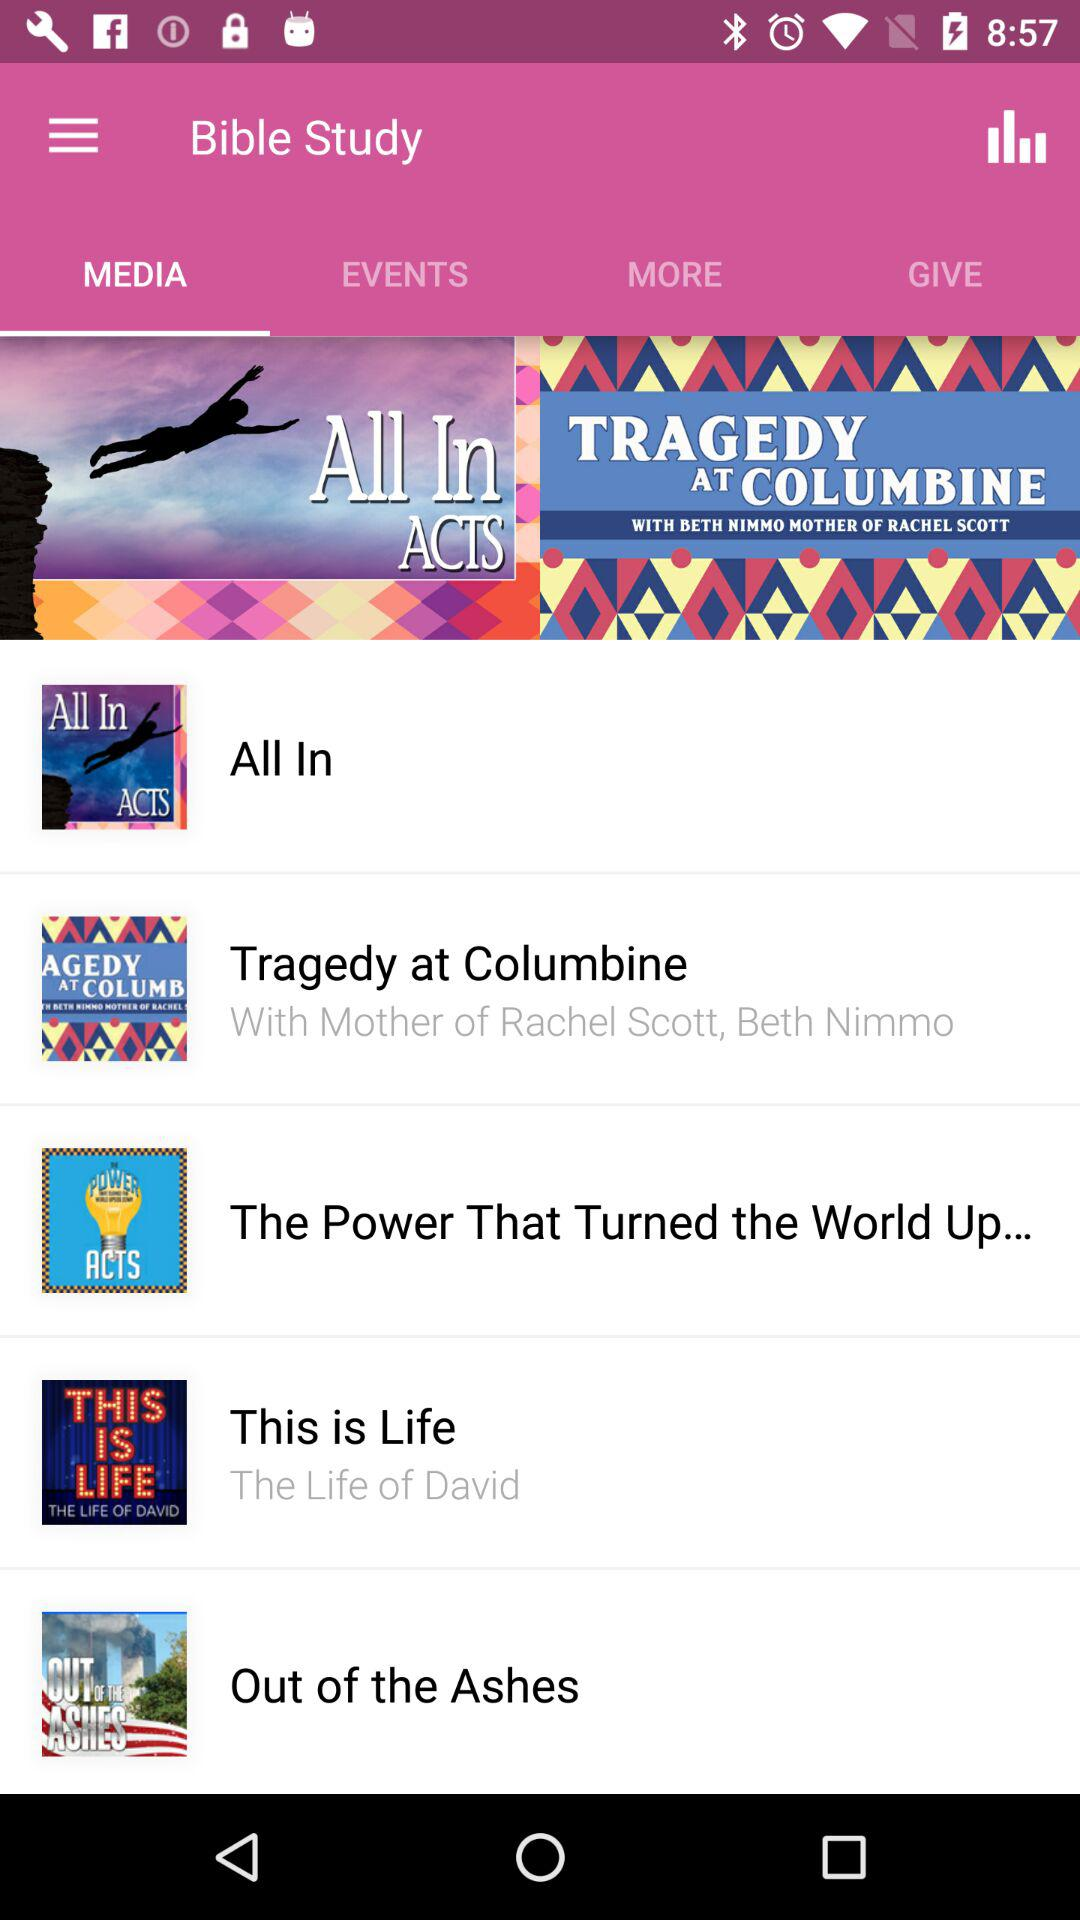Which tab is selected? The selected tab is "MEDIA". 